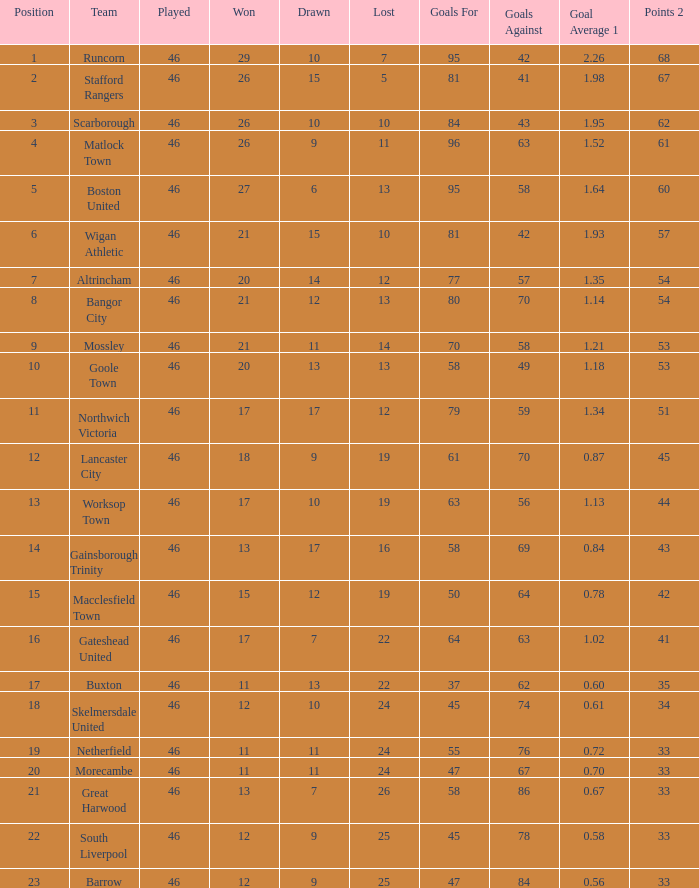Identify all losses where the mean goal count is 1.21. 14.0. 